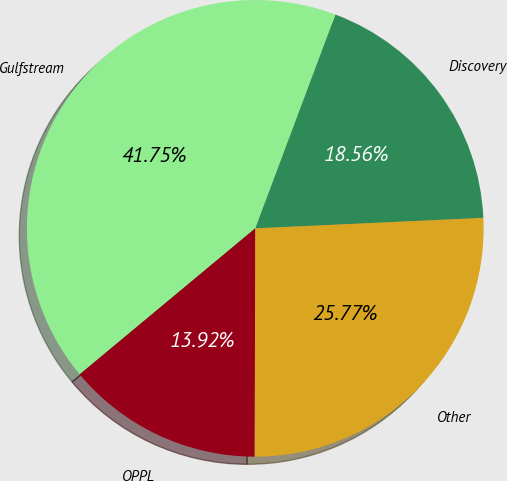Convert chart to OTSL. <chart><loc_0><loc_0><loc_500><loc_500><pie_chart><fcel>Discovery<fcel>Gulfstream<fcel>OPPL<fcel>Other<nl><fcel>18.56%<fcel>41.75%<fcel>13.92%<fcel>25.77%<nl></chart> 